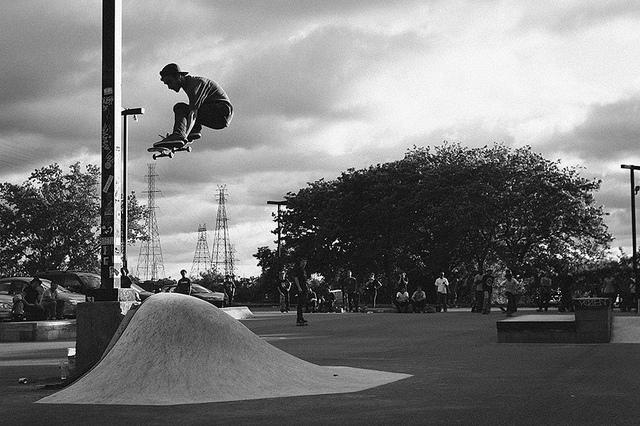Are there trees in the photo?
Be succinct. Yes. What is he doing?
Keep it brief. Skateboarding. About how many feet in the air is he?
Be succinct. 10. 